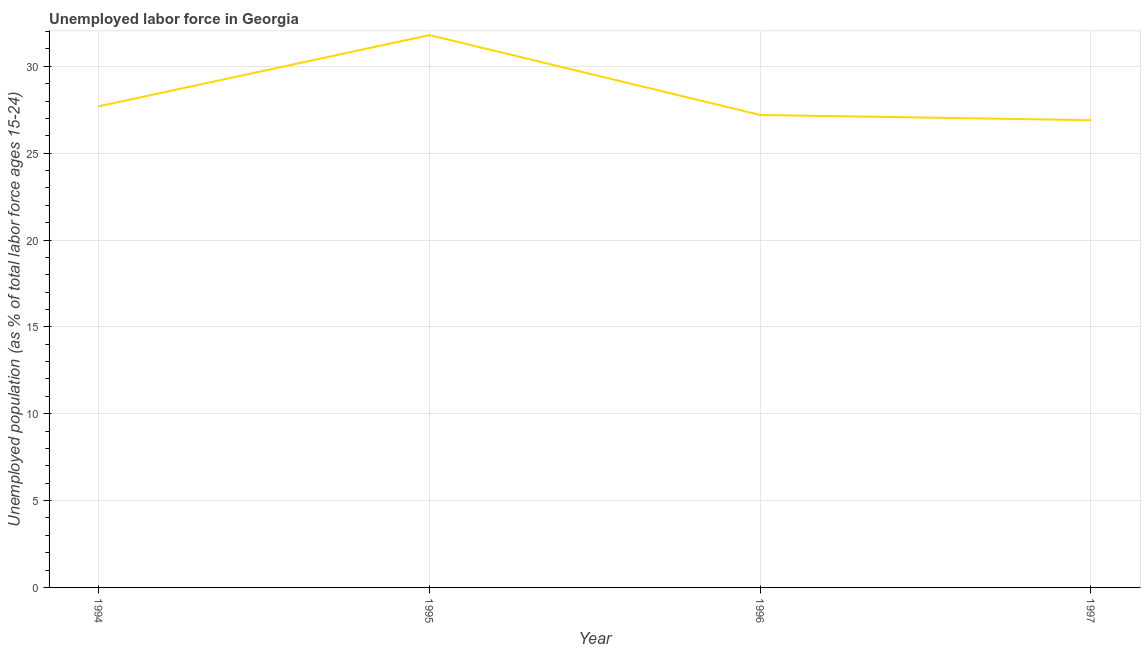What is the total unemployed youth population in 1994?
Provide a succinct answer. 27.7. Across all years, what is the maximum total unemployed youth population?
Keep it short and to the point. 31.8. Across all years, what is the minimum total unemployed youth population?
Keep it short and to the point. 26.9. In which year was the total unemployed youth population maximum?
Give a very brief answer. 1995. In which year was the total unemployed youth population minimum?
Your answer should be very brief. 1997. What is the sum of the total unemployed youth population?
Offer a very short reply. 113.6. What is the difference between the total unemployed youth population in 1994 and 1995?
Provide a succinct answer. -4.1. What is the average total unemployed youth population per year?
Make the answer very short. 28.4. What is the median total unemployed youth population?
Offer a terse response. 27.45. In how many years, is the total unemployed youth population greater than 28 %?
Your answer should be compact. 1. What is the ratio of the total unemployed youth population in 1995 to that in 1997?
Your answer should be very brief. 1.18. What is the difference between the highest and the second highest total unemployed youth population?
Offer a terse response. 4.1. Is the sum of the total unemployed youth population in 1994 and 1995 greater than the maximum total unemployed youth population across all years?
Your response must be concise. Yes. What is the difference between the highest and the lowest total unemployed youth population?
Make the answer very short. 4.9. Does the total unemployed youth population monotonically increase over the years?
Give a very brief answer. No. How many lines are there?
Ensure brevity in your answer.  1. What is the difference between two consecutive major ticks on the Y-axis?
Your response must be concise. 5. Does the graph contain any zero values?
Make the answer very short. No. Does the graph contain grids?
Offer a very short reply. Yes. What is the title of the graph?
Ensure brevity in your answer.  Unemployed labor force in Georgia. What is the label or title of the X-axis?
Offer a very short reply. Year. What is the label or title of the Y-axis?
Give a very brief answer. Unemployed population (as % of total labor force ages 15-24). What is the Unemployed population (as % of total labor force ages 15-24) in 1994?
Ensure brevity in your answer.  27.7. What is the Unemployed population (as % of total labor force ages 15-24) of 1995?
Provide a short and direct response. 31.8. What is the Unemployed population (as % of total labor force ages 15-24) of 1996?
Your answer should be compact. 27.2. What is the Unemployed population (as % of total labor force ages 15-24) in 1997?
Provide a succinct answer. 26.9. What is the difference between the Unemployed population (as % of total labor force ages 15-24) in 1994 and 1995?
Keep it short and to the point. -4.1. What is the difference between the Unemployed population (as % of total labor force ages 15-24) in 1994 and 1996?
Give a very brief answer. 0.5. What is the difference between the Unemployed population (as % of total labor force ages 15-24) in 1994 and 1997?
Your answer should be compact. 0.8. What is the difference between the Unemployed population (as % of total labor force ages 15-24) in 1995 and 1996?
Give a very brief answer. 4.6. What is the difference between the Unemployed population (as % of total labor force ages 15-24) in 1995 and 1997?
Keep it short and to the point. 4.9. What is the difference between the Unemployed population (as % of total labor force ages 15-24) in 1996 and 1997?
Keep it short and to the point. 0.3. What is the ratio of the Unemployed population (as % of total labor force ages 15-24) in 1994 to that in 1995?
Keep it short and to the point. 0.87. What is the ratio of the Unemployed population (as % of total labor force ages 15-24) in 1994 to that in 1996?
Give a very brief answer. 1.02. What is the ratio of the Unemployed population (as % of total labor force ages 15-24) in 1995 to that in 1996?
Offer a terse response. 1.17. What is the ratio of the Unemployed population (as % of total labor force ages 15-24) in 1995 to that in 1997?
Keep it short and to the point. 1.18. What is the ratio of the Unemployed population (as % of total labor force ages 15-24) in 1996 to that in 1997?
Keep it short and to the point. 1.01. 